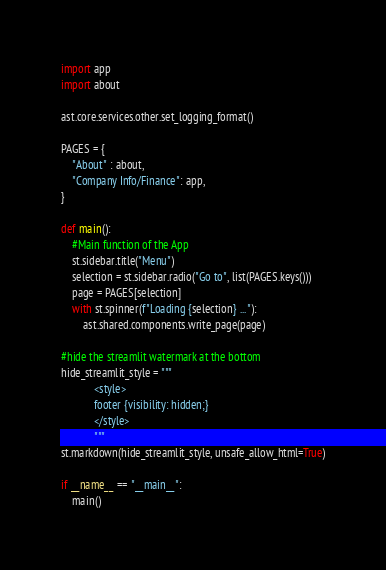<code> <loc_0><loc_0><loc_500><loc_500><_Python_>import app
import about

ast.core.services.other.set_logging_format()

PAGES = {
    "About" : about,
    "Company Info/Finance": app,
}

def main():
    #Main function of the App
    st.sidebar.title("Menu")
    selection = st.sidebar.radio("Go to", list(PAGES.keys()))
    page = PAGES[selection]
    with st.spinner(f"Loading {selection} ..."):
        ast.shared.components.write_page(page)
        
#hide the streamlit watermark at the bottom
hide_streamlit_style = """
            <style>
            footer {visibility: hidden;}
            </style>
            """
st.markdown(hide_streamlit_style, unsafe_allow_html=True)

if __name__ == "__main__":
    main()
</code> 